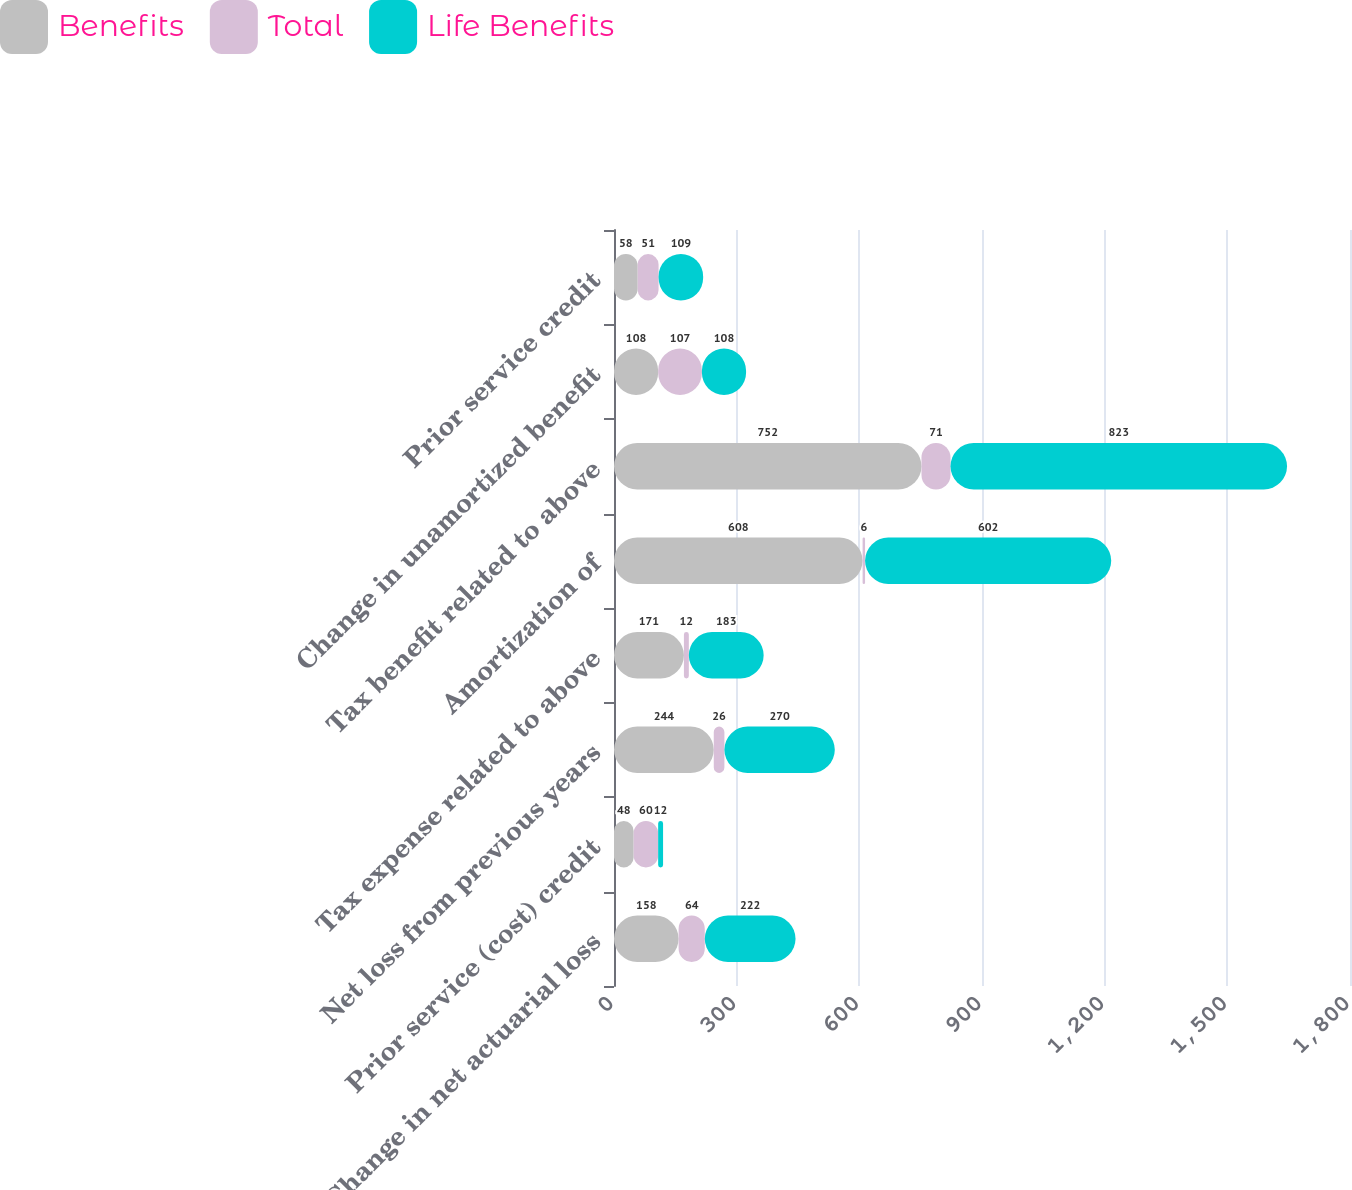<chart> <loc_0><loc_0><loc_500><loc_500><stacked_bar_chart><ecel><fcel>Change in net actuarial loss<fcel>Prior service (cost) credit<fcel>Net loss from previous years<fcel>Tax expense related to above<fcel>Amortization of<fcel>Tax benefit related to above<fcel>Change in unamortized benefit<fcel>Prior service credit<nl><fcel>Benefits<fcel>158<fcel>48<fcel>244<fcel>171<fcel>608<fcel>752<fcel>108<fcel>58<nl><fcel>Total<fcel>64<fcel>60<fcel>26<fcel>12<fcel>6<fcel>71<fcel>107<fcel>51<nl><fcel>Life Benefits<fcel>222<fcel>12<fcel>270<fcel>183<fcel>602<fcel>823<fcel>108<fcel>109<nl></chart> 